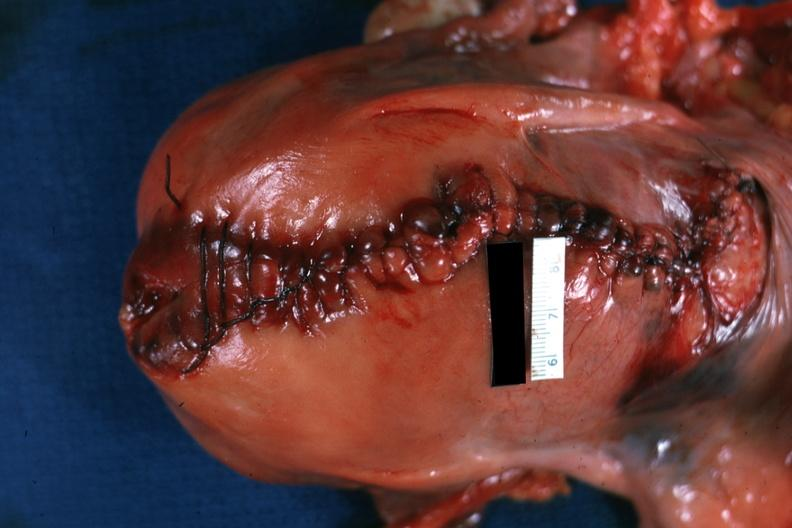s hematoma present?
Answer the question using a single word or phrase. No 